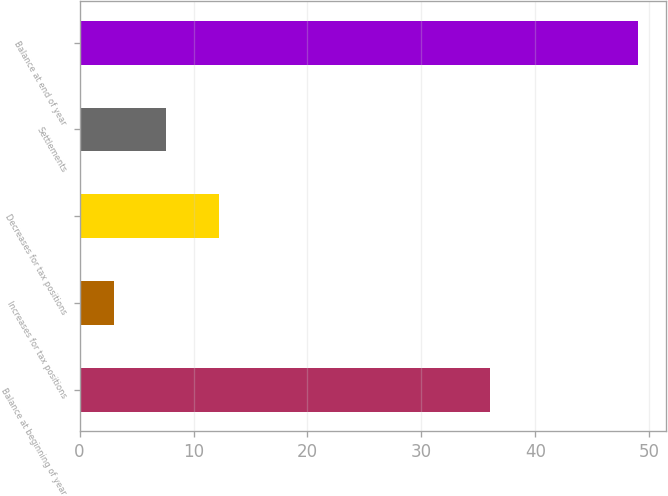Convert chart to OTSL. <chart><loc_0><loc_0><loc_500><loc_500><bar_chart><fcel>Balance at beginning of year<fcel>Increases for tax positions<fcel>Decreases for tax positions<fcel>Settlements<fcel>Balance at end of year<nl><fcel>36<fcel>3<fcel>12.2<fcel>7.6<fcel>49<nl></chart> 